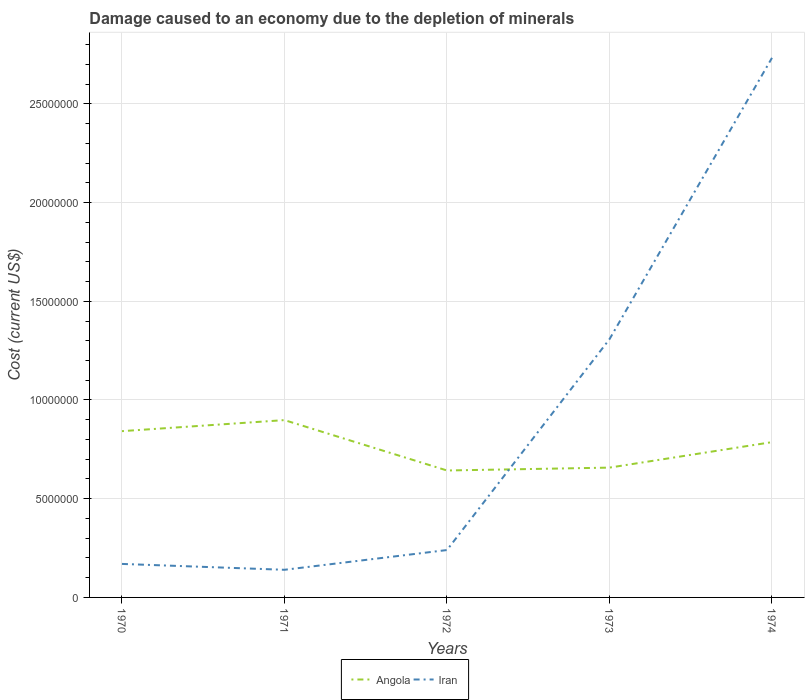How many different coloured lines are there?
Provide a short and direct response. 2. Is the number of lines equal to the number of legend labels?
Offer a very short reply. Yes. Across all years, what is the maximum cost of damage caused due to the depletion of minerals in Iran?
Your response must be concise. 1.40e+06. In which year was the cost of damage caused due to the depletion of minerals in Angola maximum?
Your answer should be very brief. 1972. What is the total cost of damage caused due to the depletion of minerals in Angola in the graph?
Your answer should be compact. -5.59e+05. What is the difference between the highest and the second highest cost of damage caused due to the depletion of minerals in Iran?
Provide a short and direct response. 2.59e+07. Is the cost of damage caused due to the depletion of minerals in Angola strictly greater than the cost of damage caused due to the depletion of minerals in Iran over the years?
Offer a very short reply. No. How many lines are there?
Keep it short and to the point. 2. How many years are there in the graph?
Your response must be concise. 5. Are the values on the major ticks of Y-axis written in scientific E-notation?
Offer a terse response. No. How many legend labels are there?
Give a very brief answer. 2. What is the title of the graph?
Offer a terse response. Damage caused to an economy due to the depletion of minerals. What is the label or title of the Y-axis?
Give a very brief answer. Cost (current US$). What is the Cost (current US$) of Angola in 1970?
Offer a terse response. 8.42e+06. What is the Cost (current US$) of Iran in 1970?
Keep it short and to the point. 1.70e+06. What is the Cost (current US$) of Angola in 1971?
Ensure brevity in your answer.  8.98e+06. What is the Cost (current US$) in Iran in 1971?
Provide a short and direct response. 1.40e+06. What is the Cost (current US$) of Angola in 1972?
Make the answer very short. 6.43e+06. What is the Cost (current US$) in Iran in 1972?
Provide a succinct answer. 2.40e+06. What is the Cost (current US$) in Angola in 1973?
Provide a succinct answer. 6.57e+06. What is the Cost (current US$) of Iran in 1973?
Offer a terse response. 1.31e+07. What is the Cost (current US$) of Angola in 1974?
Ensure brevity in your answer.  7.87e+06. What is the Cost (current US$) of Iran in 1974?
Your answer should be very brief. 2.73e+07. Across all years, what is the maximum Cost (current US$) in Angola?
Your answer should be very brief. 8.98e+06. Across all years, what is the maximum Cost (current US$) of Iran?
Give a very brief answer. 2.73e+07. Across all years, what is the minimum Cost (current US$) in Angola?
Provide a succinct answer. 6.43e+06. Across all years, what is the minimum Cost (current US$) in Iran?
Make the answer very short. 1.40e+06. What is the total Cost (current US$) of Angola in the graph?
Your answer should be compact. 3.83e+07. What is the total Cost (current US$) of Iran in the graph?
Provide a succinct answer. 4.59e+07. What is the difference between the Cost (current US$) in Angola in 1970 and that in 1971?
Your answer should be very brief. -5.59e+05. What is the difference between the Cost (current US$) in Iran in 1970 and that in 1971?
Offer a very short reply. 2.97e+05. What is the difference between the Cost (current US$) in Angola in 1970 and that in 1972?
Offer a very short reply. 1.99e+06. What is the difference between the Cost (current US$) in Iran in 1970 and that in 1972?
Provide a succinct answer. -7.03e+05. What is the difference between the Cost (current US$) of Angola in 1970 and that in 1973?
Provide a short and direct response. 1.85e+06. What is the difference between the Cost (current US$) of Iran in 1970 and that in 1973?
Provide a short and direct response. -1.14e+07. What is the difference between the Cost (current US$) in Angola in 1970 and that in 1974?
Make the answer very short. 5.56e+05. What is the difference between the Cost (current US$) of Iran in 1970 and that in 1974?
Keep it short and to the point. -2.56e+07. What is the difference between the Cost (current US$) of Angola in 1971 and that in 1972?
Your response must be concise. 2.55e+06. What is the difference between the Cost (current US$) in Iran in 1971 and that in 1972?
Offer a terse response. -1.00e+06. What is the difference between the Cost (current US$) in Angola in 1971 and that in 1973?
Offer a very short reply. 2.41e+06. What is the difference between the Cost (current US$) in Iran in 1971 and that in 1973?
Ensure brevity in your answer.  -1.17e+07. What is the difference between the Cost (current US$) of Angola in 1971 and that in 1974?
Your response must be concise. 1.12e+06. What is the difference between the Cost (current US$) of Iran in 1971 and that in 1974?
Provide a short and direct response. -2.59e+07. What is the difference between the Cost (current US$) of Angola in 1972 and that in 1973?
Your answer should be very brief. -1.45e+05. What is the difference between the Cost (current US$) of Iran in 1972 and that in 1973?
Your response must be concise. -1.07e+07. What is the difference between the Cost (current US$) in Angola in 1972 and that in 1974?
Your response must be concise. -1.44e+06. What is the difference between the Cost (current US$) in Iran in 1972 and that in 1974?
Your answer should be very brief. -2.49e+07. What is the difference between the Cost (current US$) in Angola in 1973 and that in 1974?
Provide a succinct answer. -1.29e+06. What is the difference between the Cost (current US$) of Iran in 1973 and that in 1974?
Give a very brief answer. -1.42e+07. What is the difference between the Cost (current US$) of Angola in 1970 and the Cost (current US$) of Iran in 1971?
Give a very brief answer. 7.02e+06. What is the difference between the Cost (current US$) of Angola in 1970 and the Cost (current US$) of Iran in 1972?
Give a very brief answer. 6.02e+06. What is the difference between the Cost (current US$) in Angola in 1970 and the Cost (current US$) in Iran in 1973?
Provide a succinct answer. -4.66e+06. What is the difference between the Cost (current US$) of Angola in 1970 and the Cost (current US$) of Iran in 1974?
Offer a very short reply. -1.89e+07. What is the difference between the Cost (current US$) of Angola in 1971 and the Cost (current US$) of Iran in 1972?
Give a very brief answer. 6.58e+06. What is the difference between the Cost (current US$) of Angola in 1971 and the Cost (current US$) of Iran in 1973?
Give a very brief answer. -4.10e+06. What is the difference between the Cost (current US$) of Angola in 1971 and the Cost (current US$) of Iran in 1974?
Give a very brief answer. -1.83e+07. What is the difference between the Cost (current US$) in Angola in 1972 and the Cost (current US$) in Iran in 1973?
Provide a succinct answer. -6.65e+06. What is the difference between the Cost (current US$) of Angola in 1972 and the Cost (current US$) of Iran in 1974?
Offer a terse response. -2.09e+07. What is the difference between the Cost (current US$) in Angola in 1973 and the Cost (current US$) in Iran in 1974?
Offer a very short reply. -2.08e+07. What is the average Cost (current US$) of Angola per year?
Your response must be concise. 7.65e+06. What is the average Cost (current US$) in Iran per year?
Your answer should be very brief. 9.18e+06. In the year 1970, what is the difference between the Cost (current US$) of Angola and Cost (current US$) of Iran?
Provide a short and direct response. 6.72e+06. In the year 1971, what is the difference between the Cost (current US$) of Angola and Cost (current US$) of Iran?
Make the answer very short. 7.58e+06. In the year 1972, what is the difference between the Cost (current US$) in Angola and Cost (current US$) in Iran?
Keep it short and to the point. 4.03e+06. In the year 1973, what is the difference between the Cost (current US$) of Angola and Cost (current US$) of Iran?
Give a very brief answer. -6.51e+06. In the year 1974, what is the difference between the Cost (current US$) of Angola and Cost (current US$) of Iran?
Provide a succinct answer. -1.95e+07. What is the ratio of the Cost (current US$) in Angola in 1970 to that in 1971?
Your answer should be compact. 0.94. What is the ratio of the Cost (current US$) in Iran in 1970 to that in 1971?
Provide a succinct answer. 1.21. What is the ratio of the Cost (current US$) of Angola in 1970 to that in 1972?
Make the answer very short. 1.31. What is the ratio of the Cost (current US$) in Iran in 1970 to that in 1972?
Offer a terse response. 0.71. What is the ratio of the Cost (current US$) in Angola in 1970 to that in 1973?
Offer a terse response. 1.28. What is the ratio of the Cost (current US$) of Iran in 1970 to that in 1973?
Your response must be concise. 0.13. What is the ratio of the Cost (current US$) in Angola in 1970 to that in 1974?
Provide a succinct answer. 1.07. What is the ratio of the Cost (current US$) in Iran in 1970 to that in 1974?
Make the answer very short. 0.06. What is the ratio of the Cost (current US$) of Angola in 1971 to that in 1972?
Provide a short and direct response. 1.4. What is the ratio of the Cost (current US$) in Iran in 1971 to that in 1972?
Your answer should be compact. 0.58. What is the ratio of the Cost (current US$) in Angola in 1971 to that in 1973?
Your answer should be very brief. 1.37. What is the ratio of the Cost (current US$) in Iran in 1971 to that in 1973?
Your answer should be very brief. 0.11. What is the ratio of the Cost (current US$) of Angola in 1971 to that in 1974?
Provide a succinct answer. 1.14. What is the ratio of the Cost (current US$) of Iran in 1971 to that in 1974?
Make the answer very short. 0.05. What is the ratio of the Cost (current US$) in Angola in 1972 to that in 1973?
Give a very brief answer. 0.98. What is the ratio of the Cost (current US$) in Iran in 1972 to that in 1973?
Offer a terse response. 0.18. What is the ratio of the Cost (current US$) in Angola in 1972 to that in 1974?
Make the answer very short. 0.82. What is the ratio of the Cost (current US$) in Iran in 1972 to that in 1974?
Provide a succinct answer. 0.09. What is the ratio of the Cost (current US$) of Angola in 1973 to that in 1974?
Ensure brevity in your answer.  0.84. What is the ratio of the Cost (current US$) of Iran in 1973 to that in 1974?
Your response must be concise. 0.48. What is the difference between the highest and the second highest Cost (current US$) in Angola?
Your answer should be very brief. 5.59e+05. What is the difference between the highest and the second highest Cost (current US$) in Iran?
Provide a succinct answer. 1.42e+07. What is the difference between the highest and the lowest Cost (current US$) in Angola?
Keep it short and to the point. 2.55e+06. What is the difference between the highest and the lowest Cost (current US$) in Iran?
Offer a very short reply. 2.59e+07. 